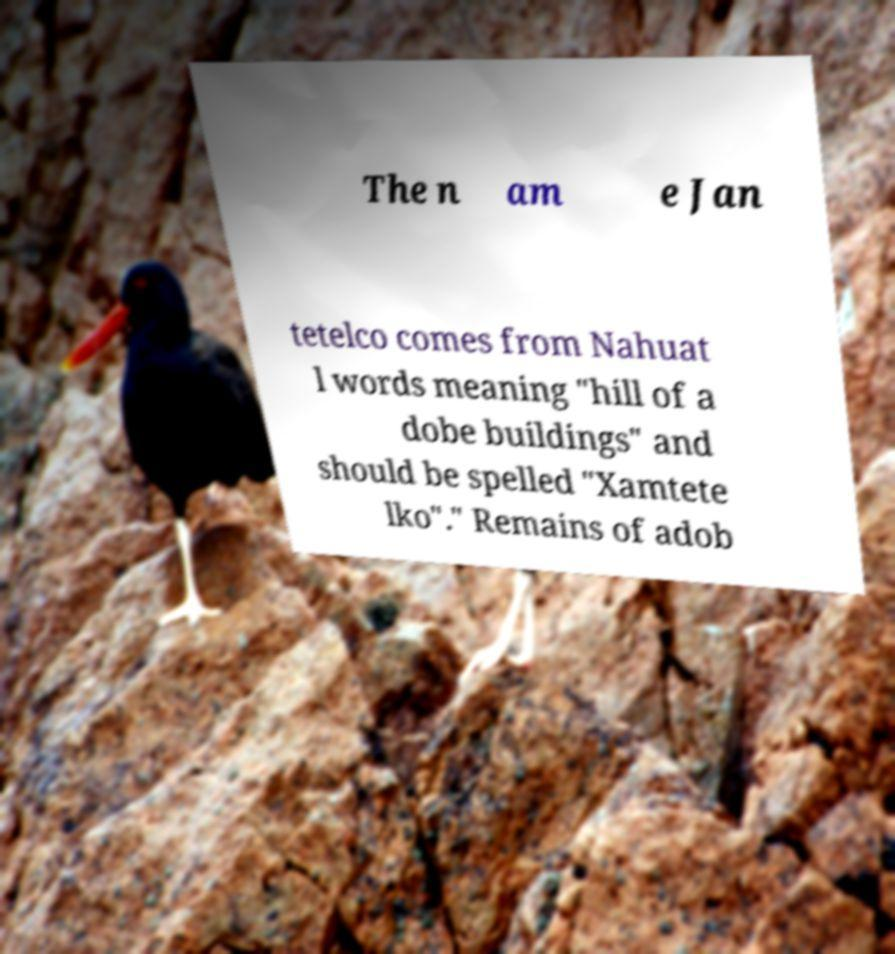Can you read and provide the text displayed in the image?This photo seems to have some interesting text. Can you extract and type it out for me? The n am e Jan tetelco comes from Nahuat l words meaning "hill of a dobe buildings" and should be spelled "Xamtete lko"." Remains of adob 